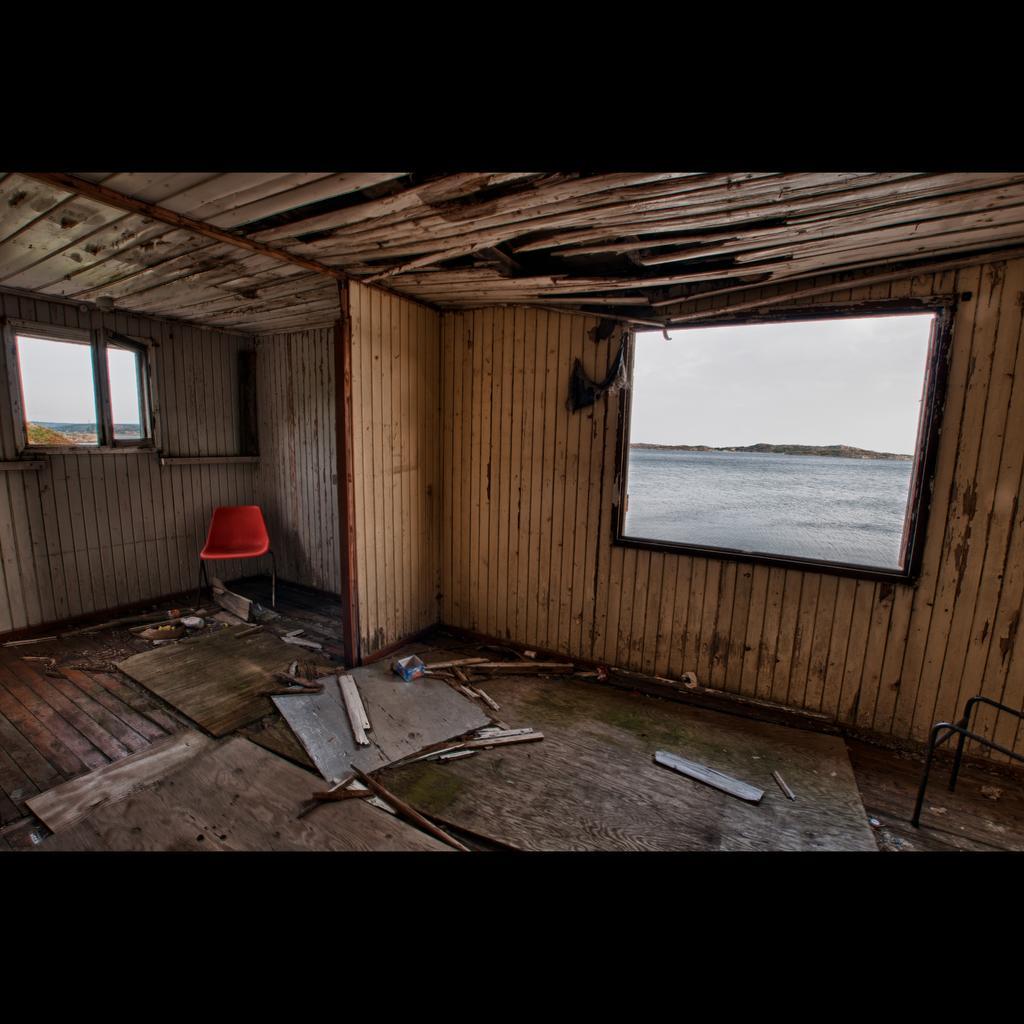Describe this image in one or two sentences. In this image I can see a wooden house. I can see windows,red chair,water and few wooden sticks. The sky is in white color. 